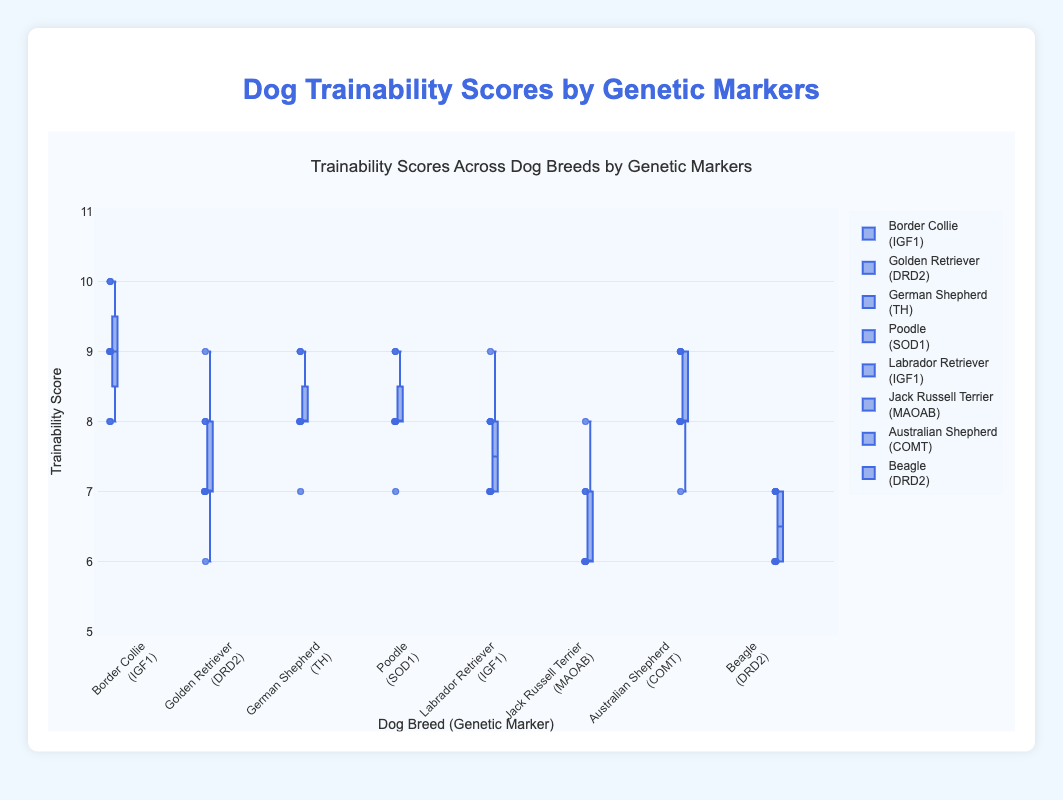What breeds have the highest median trainability scores? Look at the middle line in each box plot to determine the median scores. The breeds with the highest medians are Border Collie and Australian Shepherd.
Answer: Border Collie, Australian Shepherd Which dog breed has the widest range in its trainability scores? The range is the difference between the whiskers (minimum and maximum). The breed with the widest range is the Golden Retriever.
Answer: Golden Retriever Which genetic marker is associated with the consistently highest trainability scores? Focus on the breeds with high scores and their corresponding genetic markers. Border Collie with IGF1 has consistently high scores.
Answer: IGF1 Are there any breeds with a completely overlapping interquartile range (IQR)? The IQR is the box itself, which spans from the first to the third quartile. Compare the boxes to see if any overlap completely. The German Shepherd and the Poodle overlap significantly but do not completely overlap.
Answer: No Which breed has the lowest median trainability score? Look at the middle line in each box plot to find the lowest. The breed with the lowest median is the Jack Russell Terrier.
Answer: Jack Russell Terrier What is the interquartile range (IQR) for the Labrador Retriever's trainability scores? The IQR is the difference between the upper quartile (75th percentile) and the lower quartile (25th percentile). For Labrador Retriever, the upper quartile is 8 and the lower quartile is 7.
Answer: 1 Which breeds have a median trainability score that is equal to 8? Look for the middle line in the box plots and see which breeds' medians align with the y-axis value of 8. The breeds include German Shepherd, Poodle, and Australian Shepherd.
Answer: German Shepherd, Poodle, Australian Shepherd How do the trainability scores of breeds with the DRD2 genetic marker compare? Look at the box plots for Golden Retriever and Beagle, and compare their ranges, medians, and overall distribution. Both breeds have overlapping scores but Golden Retriever has higher max values.
Answer: Golden Retriever generally higher Which breed has the least variability in its trainability scores? Variability can be seen as the length of the whiskers. The breed with the least variability (shorter whiskers) is the Poodle.
Answer: Poodle 